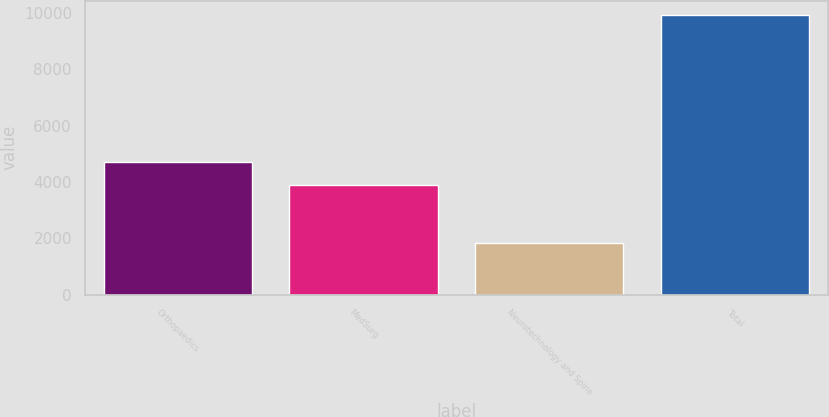Convert chart to OTSL. <chart><loc_0><loc_0><loc_500><loc_500><bar_chart><fcel>Orthopaedics<fcel>MedSurg<fcel>Neurotechnology and Spine<fcel>Total<nl><fcel>4706.8<fcel>3895<fcel>1828<fcel>9946<nl></chart> 